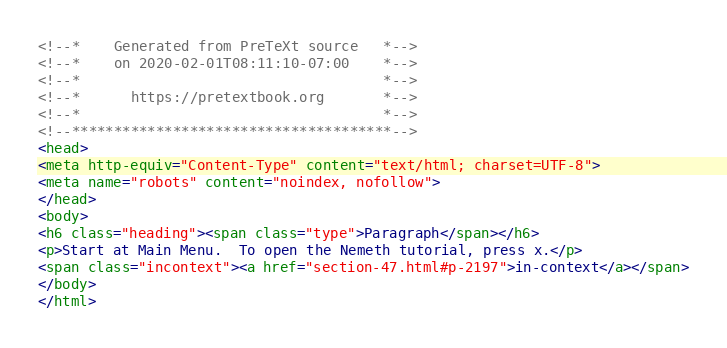<code> <loc_0><loc_0><loc_500><loc_500><_HTML_><!--*    Generated from PreTeXt source   *-->
<!--*    on 2020-02-01T08:11:10-07:00    *-->
<!--*                                    *-->
<!--*      https://pretextbook.org       *-->
<!--*                                    *-->
<!--**************************************-->
<head>
<meta http-equiv="Content-Type" content="text/html; charset=UTF-8">
<meta name="robots" content="noindex, nofollow">
</head>
<body>
<h6 class="heading"><span class="type">Paragraph</span></h6>
<p>Start at Main Menu.  To open the Nemeth tutorial, press x.</p>
<span class="incontext"><a href="section-47.html#p-2197">in-context</a></span>
</body>
</html>
</code> 